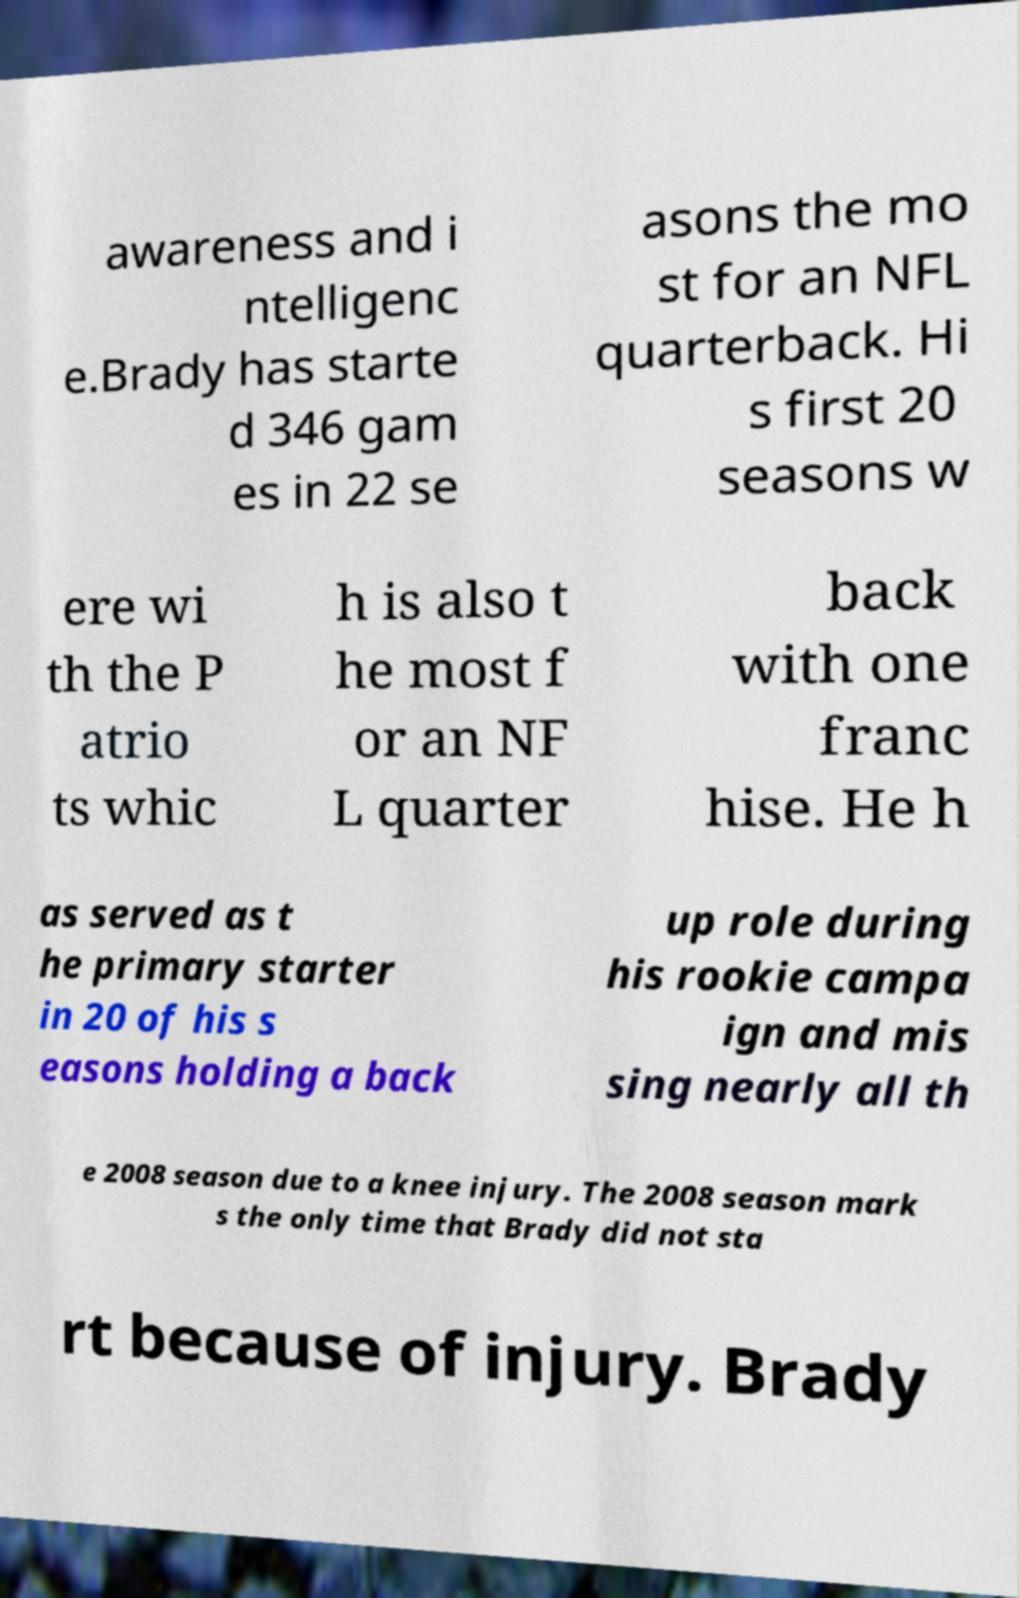There's text embedded in this image that I need extracted. Can you transcribe it verbatim? awareness and i ntelligenc e.Brady has starte d 346 gam es in 22 se asons the mo st for an NFL quarterback. Hi s first 20 seasons w ere wi th the P atrio ts whic h is also t he most f or an NF L quarter back with one franc hise. He h as served as t he primary starter in 20 of his s easons holding a back up role during his rookie campa ign and mis sing nearly all th e 2008 season due to a knee injury. The 2008 season mark s the only time that Brady did not sta rt because of injury. Brady 